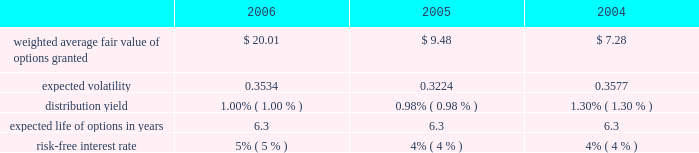The fair value for these options was estimated at the date of grant using a black-scholes option pricing model with the following weighted-average assumptions for 2006 , 2005 and 2004: .
The black-scholes option valuation model was developed for use in estimating the fair value of traded options which have no vesting restrictions and are fully transferable .
In addition , option valuation models require the input of highly subjective assumptions , including the expected stock price volatility .
Because the company 2019s employee stock options have characteristics significantly different from those of traded options , and because changes in the subjective input assumptions can materially affect the fair value estimate , in management 2019s opinion , the existing models do not necessarily provide a reliable single measure of the fair value of its employee stock options .
The total fair value of shares vested during 2006 , 2005 , and 2004 was $ 9413 , $ 8249 , and $ 6418 respectively .
The aggregate intrinsic values of options outstanding and exercisable at december 30 , 2006 were $ 204.1 million and $ 100.2 million , respectively .
The aggregate intrinsic value of options exercised during the year ended december 30 , 2006 was $ 42.8 million .
Aggregate intrinsic value represents the positive difference between the company 2019s closing stock price on the last trading day of the fiscal period , which was $ 55.66 on december 29 , 2006 , and the exercise price multiplied by the number of options outstanding .
As of december 30 , 2006 , there was $ 64.2 million of total unrecognized compensation cost related to unvested share-based compensation awards granted to employees under the option plans .
That cost is expected to be recognized over a period of five years .
Employee stock purchase plan the shareholders also adopted an employee stock purchase plan ( espp ) .
Up to 2000000 shares of common stock have been reserved for the espp .
Shares will be offered to employees at a price equal to the lesser of 85% ( 85 % ) of the fair market value of the stock on the date of purchase or 85% ( 85 % ) of the fair market value on the enrollment date .
The espp is intended to qualify as an 201cemployee stock purchase plan 201d under section 423 of the internal revenue code .
During 2006 , 2005 , and 2004 , 124693 , 112798 , and 117900 shares were purchased under the plan for a total purchase price of $ 3569 , $ 2824 , and $ 2691 , respectively .
At december 30 , 2006 , approximately 1116811 shares were available for future issuance. .
Considering the weighted average fair value of options , how many shares vested in 2004? 
Rationale: it is the total fair value of options that vested in 2004 divided by its weighted average fair value also in 2004 .
Computations: (6418 / 7.28)
Answer: 881.59341. 